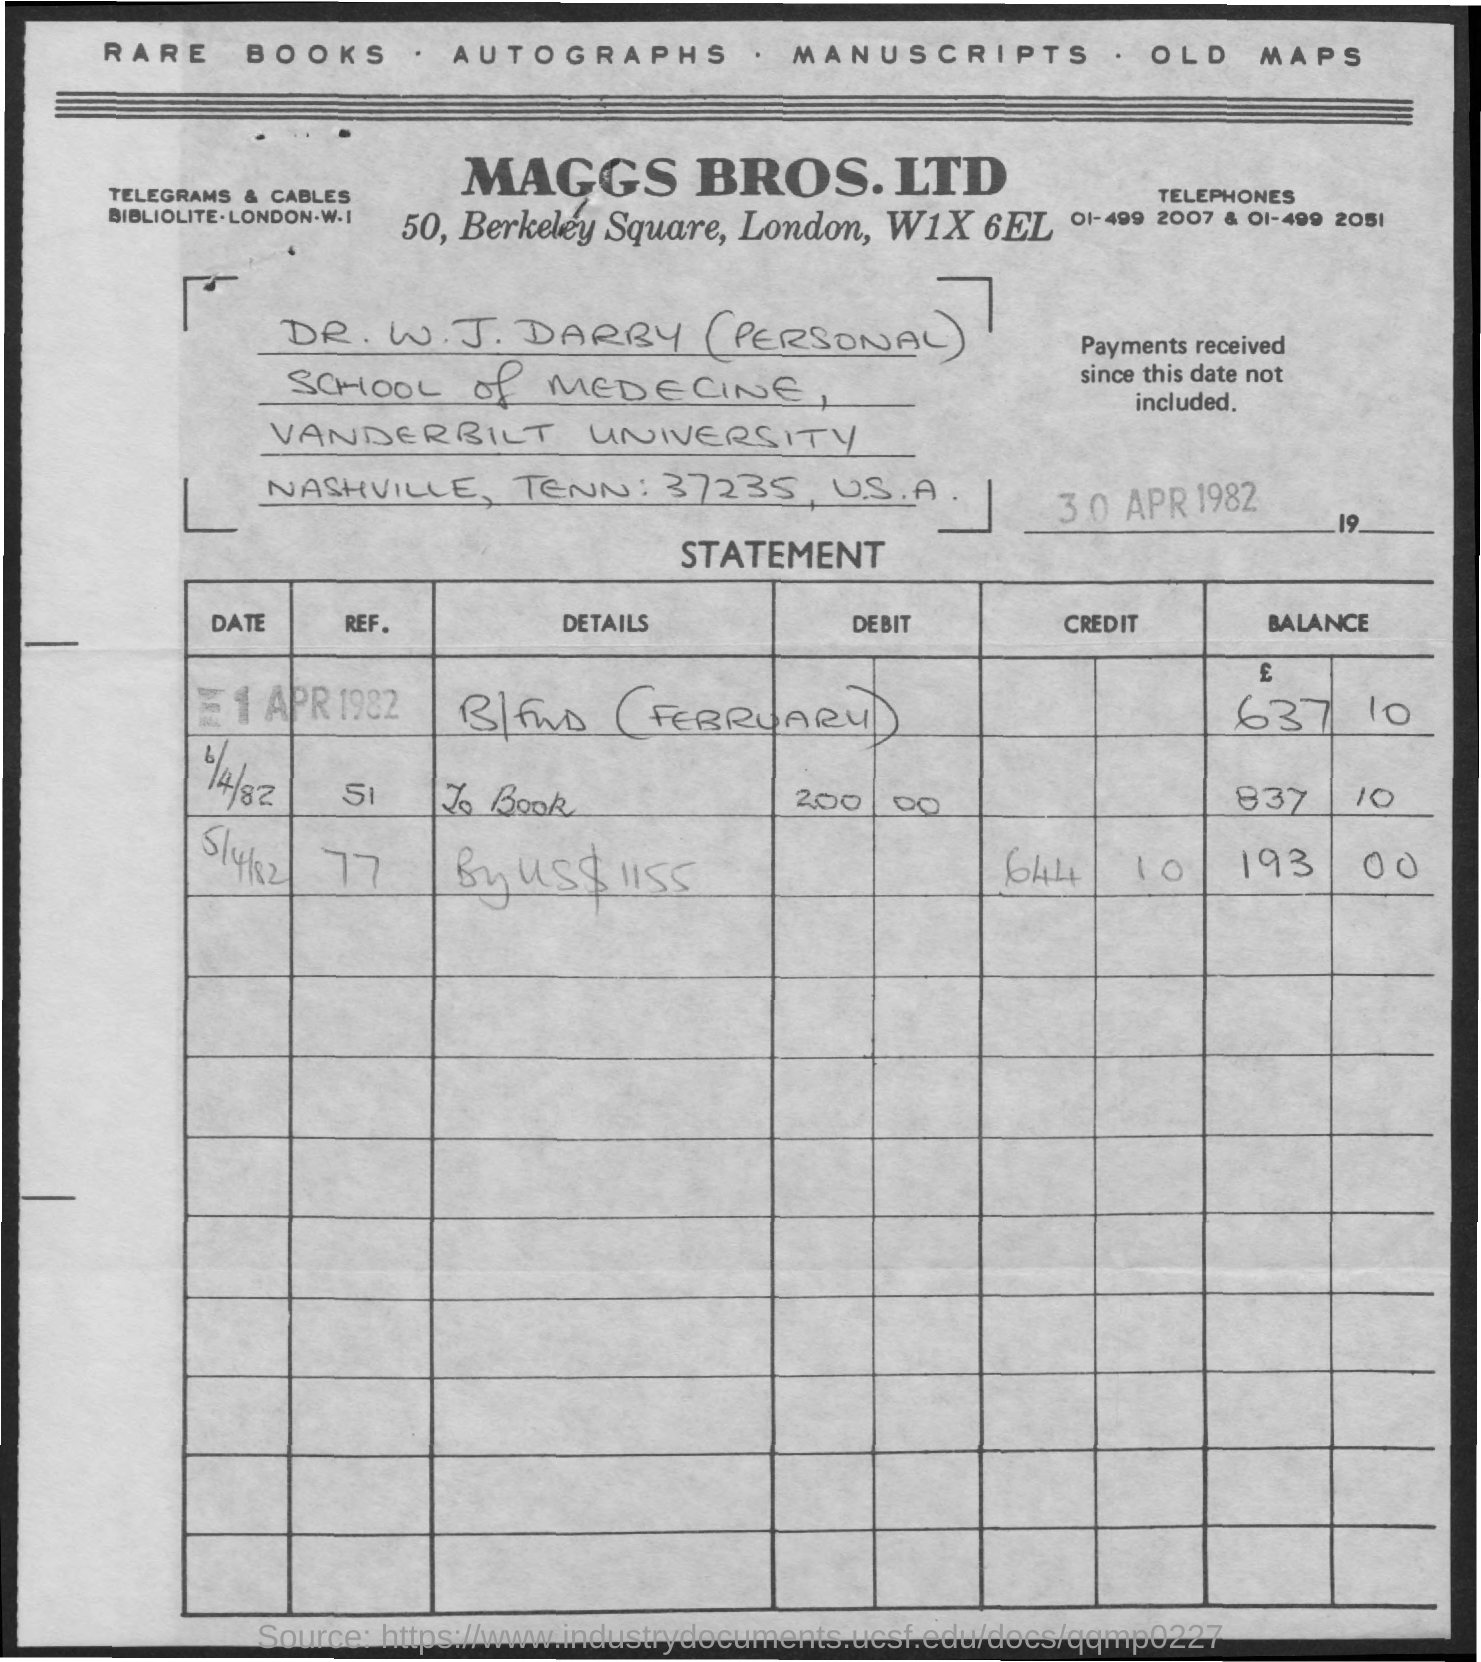When is the document dated?
Offer a very short reply. 30 APR 1982. 